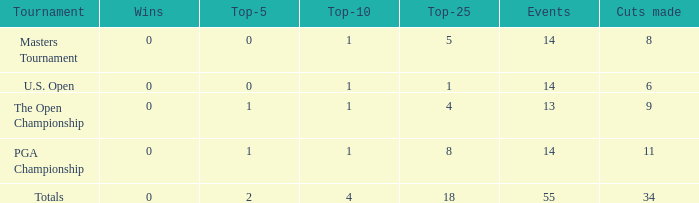What is the maximum occurrence when the reductions made are fewer than 34, the top-25 is under 5, and the top-10 is over 1? None. 